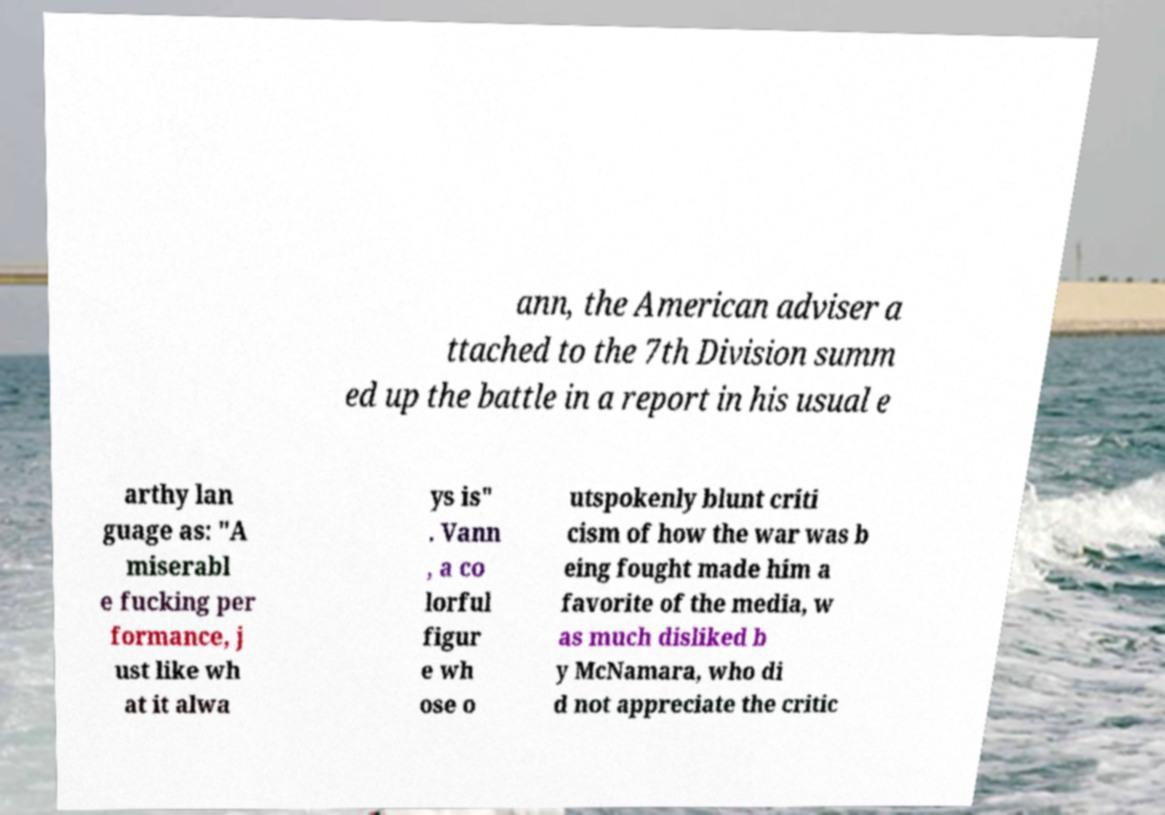Can you accurately transcribe the text from the provided image for me? ann, the American adviser a ttached to the 7th Division summ ed up the battle in a report in his usual e arthy lan guage as: "A miserabl e fucking per formance, j ust like wh at it alwa ys is" . Vann , a co lorful figur e wh ose o utspokenly blunt criti cism of how the war was b eing fought made him a favorite of the media, w as much disliked b y McNamara, who di d not appreciate the critic 